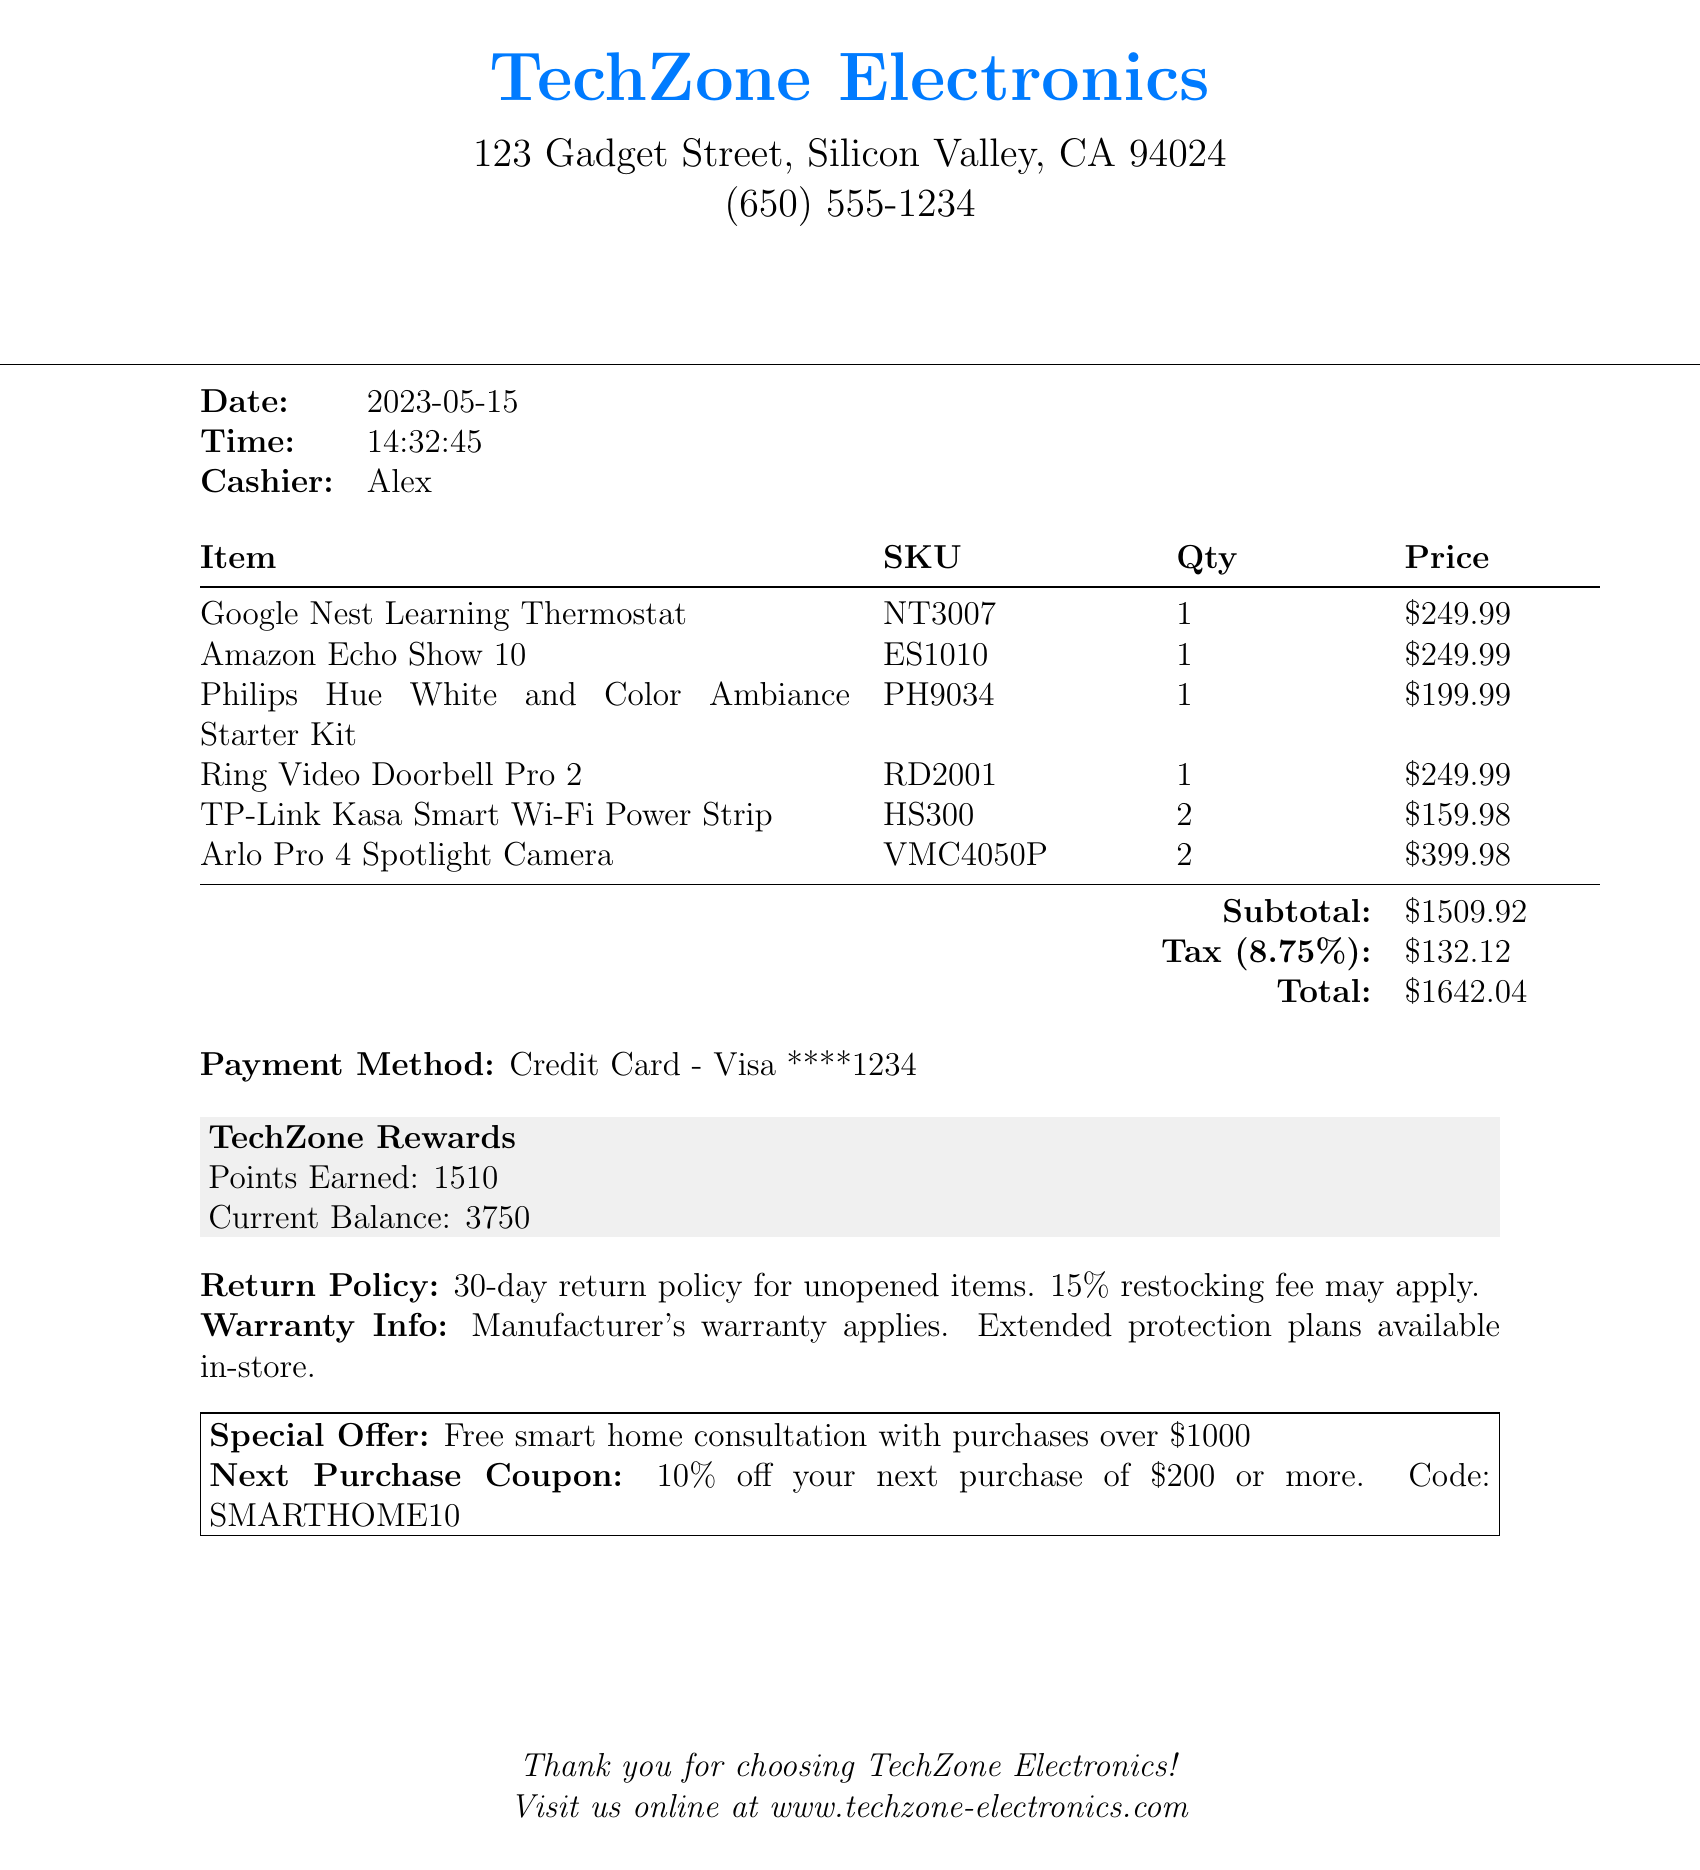What is the name of the store? The name of the store is provided at the top of the receipt.
Answer: TechZone Electronics What is the date of the transaction? The date indicates when the purchase was made.
Answer: 2023-05-15 How many Arlo Pro 4 Spotlight Cameras were purchased? The quantity purchased for each item is listed in the receipt.
Answer: 2 What is the subtotal amount? The subtotal is the total amount before tax is applied.
Answer: $1509.92 What is the tax rate applied? The tax rate is indicated as a percentage in the document.
Answer: 8.75% What is the total amount paid? The total is the final amount after tax has been added to the subtotal.
Answer: $1642.04 What loyalty program was used? The name of the loyalty program is mentioned in the receipt section.
Answer: TechZone Rewards How many points were earned from the purchase? The points earned are stated in the loyalty program section of the receipt.
Answer: 1510 What is the return policy duration? The duration of the return policy is specified in the document.
Answer: 30-day What special offer is mentioned in the receipt? The receipt includes a promotion related to the total purchase amount.
Answer: Free smart home consultation with purchases over $1000 